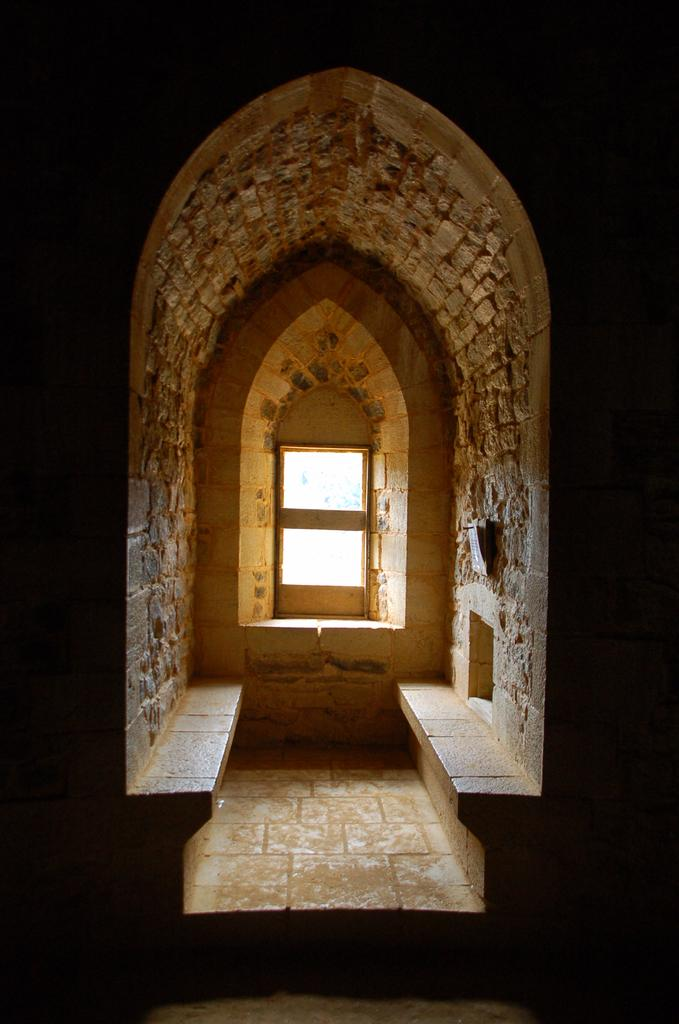What type of location is depicted in the image? The image is an inside view of a building. What type of furniture can be seen in the building? There are chairs in the building. Is there any natural light source visible in the image? Yes, there is a window inside the building. What type of beef is being cooked in the image? There is no beef or any cooking activity present in the image. What arithmetic problem is being solved on the table in the image? There is no arithmetic problem or any indication of solving a problem in the image. 